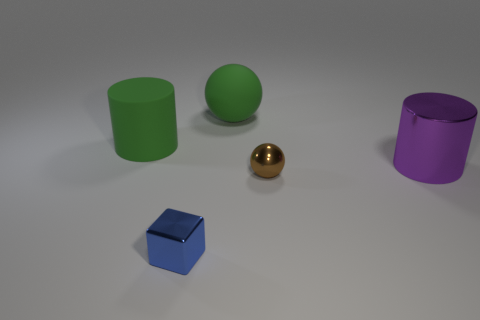Do the big object that is right of the tiny brown metallic object and the green matte object left of the large ball have the same shape?
Ensure brevity in your answer.  Yes. What is the material of the other object that is the same shape as the brown shiny thing?
Make the answer very short. Rubber. How many spheres are either small brown rubber things or brown things?
Offer a very short reply. 1. What number of green cylinders are the same material as the brown thing?
Make the answer very short. 0. Is the tiny cube in front of the brown object made of the same material as the large cylinder to the left of the brown metallic thing?
Your response must be concise. No. How many green matte objects are to the right of the green object left of the green thing on the right side of the tiny block?
Your answer should be compact. 1. There is a matte thing to the left of the metal cube; does it have the same color as the metallic object that is in front of the brown thing?
Provide a succinct answer. No. Is there any other thing of the same color as the matte sphere?
Provide a short and direct response. Yes. There is a ball behind the big thing that is right of the brown shiny ball; what color is it?
Your answer should be compact. Green. Are there any tiny gray cylinders?
Make the answer very short. No. 